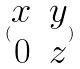<formula> <loc_0><loc_0><loc_500><loc_500>( \begin{matrix} x & y \\ 0 & z \end{matrix} )</formula> 